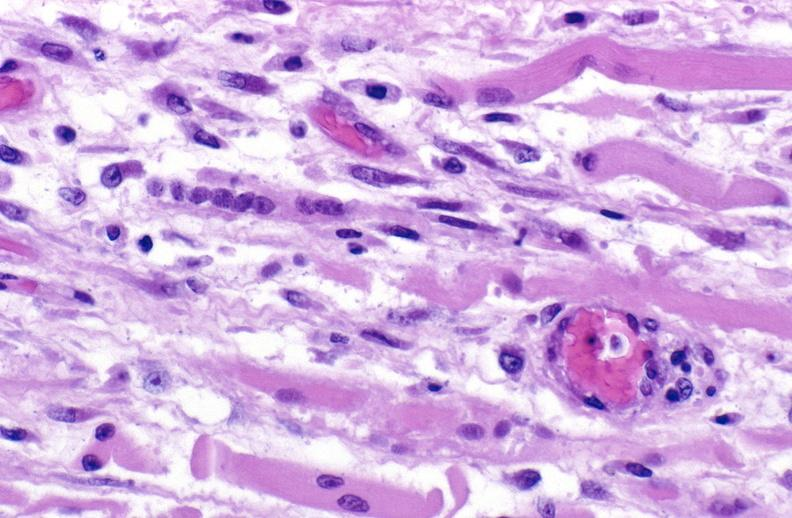what does this image show?
Answer the question using a single word or phrase. Tracheotomy site 